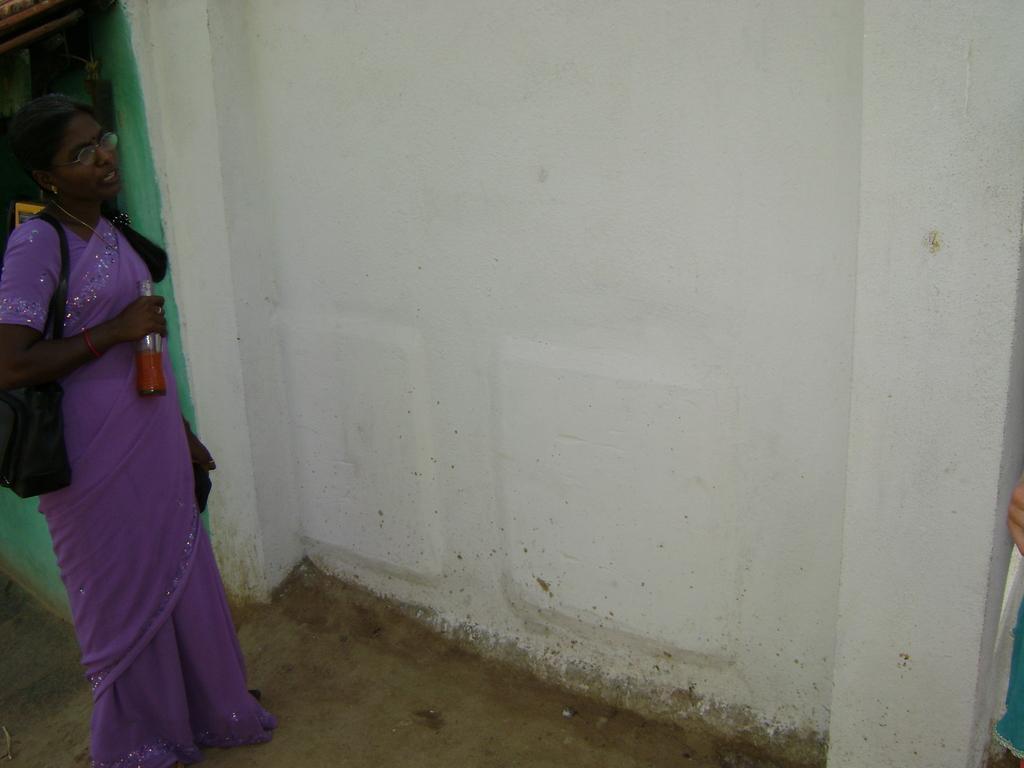Describe this image in one or two sentences. In this image I can see a person wearing purple color saree and holding a bottle, and the person is also wearing a bag which is in black color. I can also see a wall in white color. 